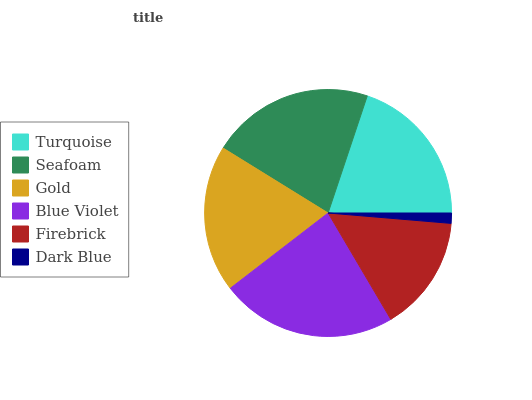Is Dark Blue the minimum?
Answer yes or no. Yes. Is Blue Violet the maximum?
Answer yes or no. Yes. Is Seafoam the minimum?
Answer yes or no. No. Is Seafoam the maximum?
Answer yes or no. No. Is Seafoam greater than Turquoise?
Answer yes or no. Yes. Is Turquoise less than Seafoam?
Answer yes or no. Yes. Is Turquoise greater than Seafoam?
Answer yes or no. No. Is Seafoam less than Turquoise?
Answer yes or no. No. Is Turquoise the high median?
Answer yes or no. Yes. Is Gold the low median?
Answer yes or no. Yes. Is Firebrick the high median?
Answer yes or no. No. Is Turquoise the low median?
Answer yes or no. No. 